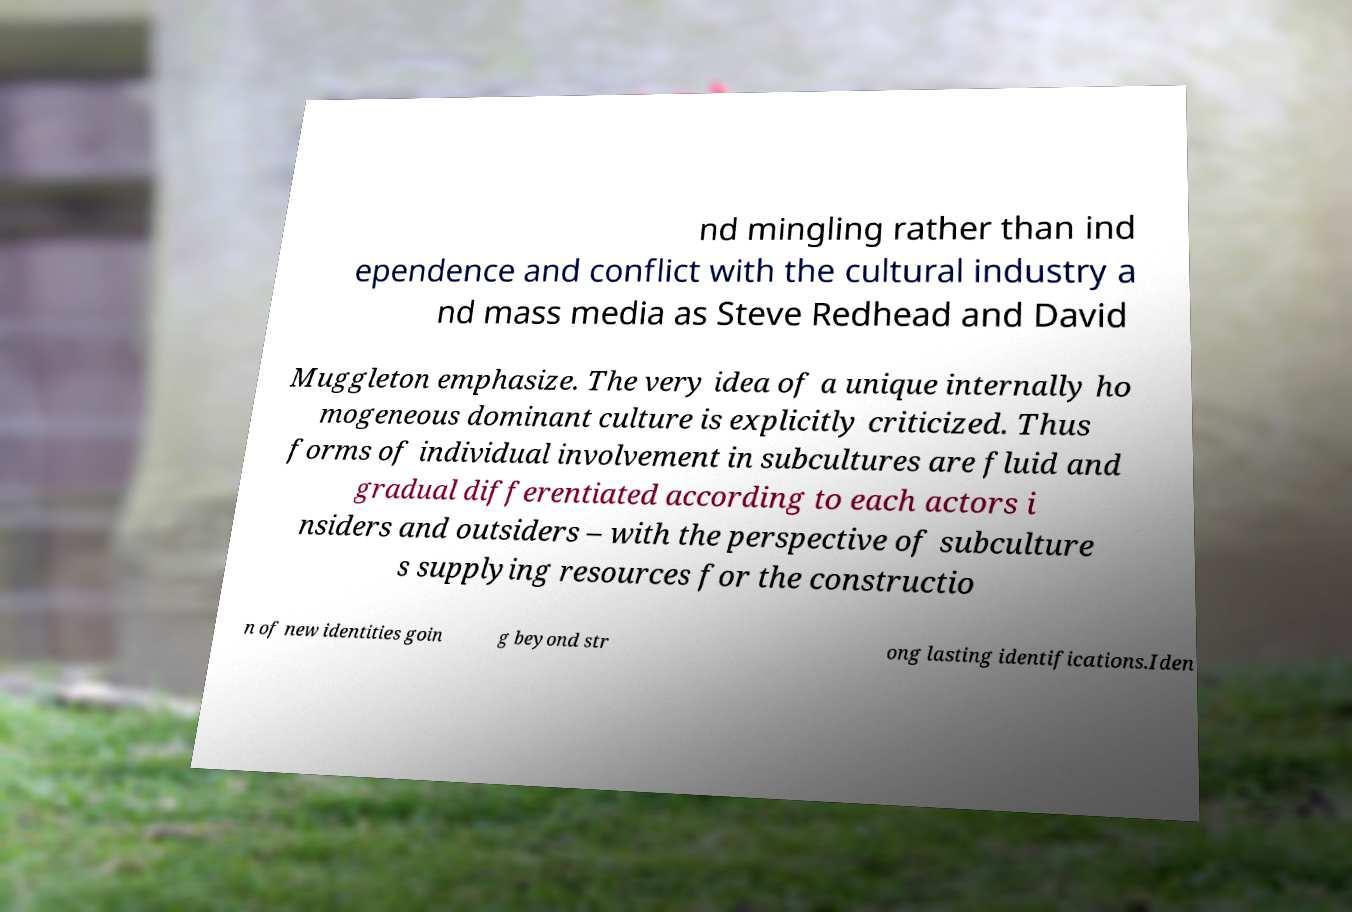Could you assist in decoding the text presented in this image and type it out clearly? nd mingling rather than ind ependence and conflict with the cultural industry a nd mass media as Steve Redhead and David Muggleton emphasize. The very idea of a unique internally ho mogeneous dominant culture is explicitly criticized. Thus forms of individual involvement in subcultures are fluid and gradual differentiated according to each actors i nsiders and outsiders – with the perspective of subculture s supplying resources for the constructio n of new identities goin g beyond str ong lasting identifications.Iden 